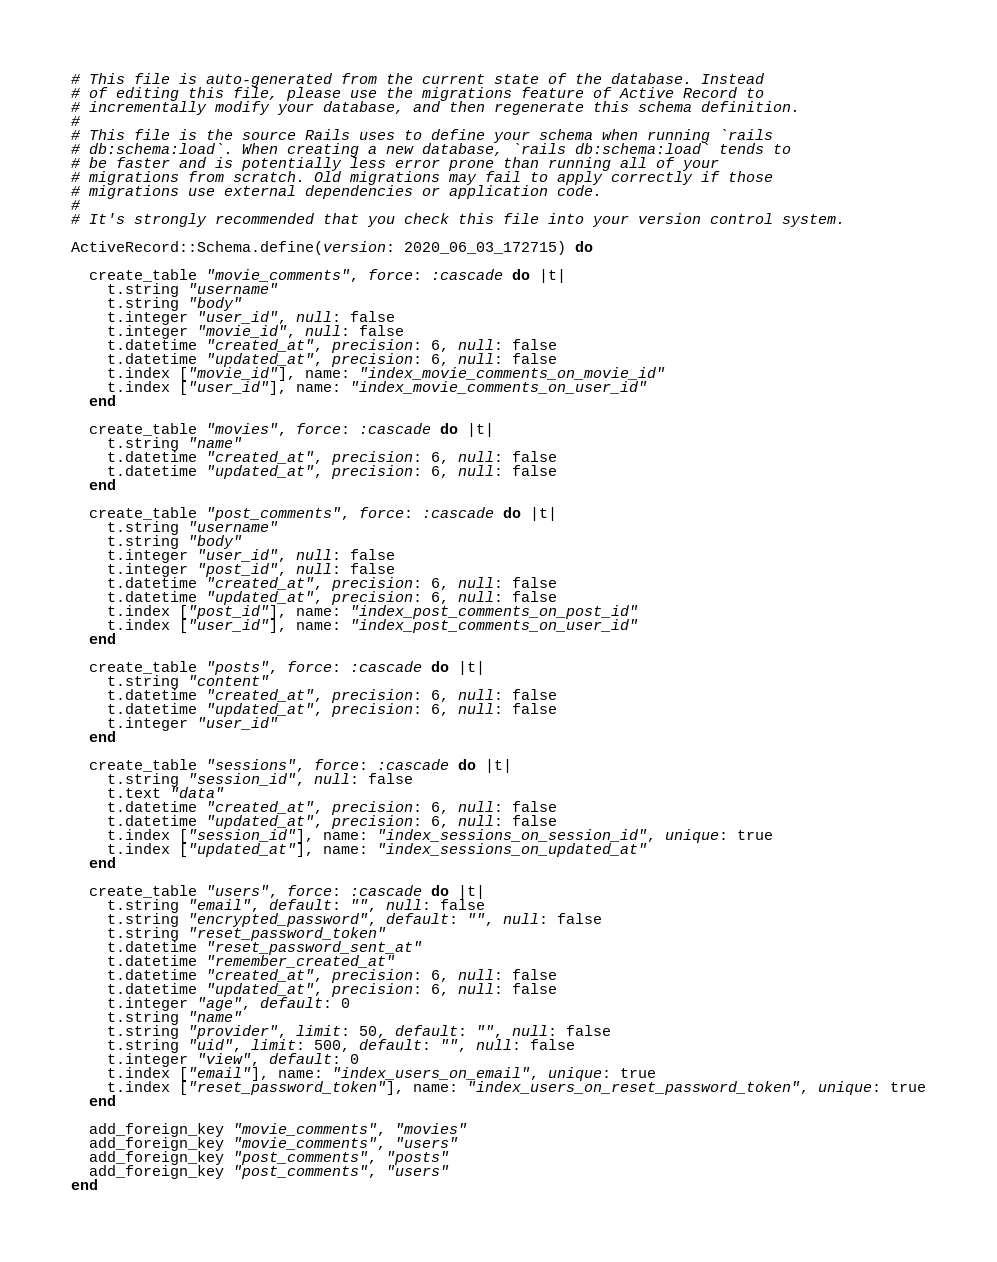<code> <loc_0><loc_0><loc_500><loc_500><_Ruby_># This file is auto-generated from the current state of the database. Instead
# of editing this file, please use the migrations feature of Active Record to
# incrementally modify your database, and then regenerate this schema definition.
#
# This file is the source Rails uses to define your schema when running `rails
# db:schema:load`. When creating a new database, `rails db:schema:load` tends to
# be faster and is potentially less error prone than running all of your
# migrations from scratch. Old migrations may fail to apply correctly if those
# migrations use external dependencies or application code.
#
# It's strongly recommended that you check this file into your version control system.

ActiveRecord::Schema.define(version: 2020_06_03_172715) do

  create_table "movie_comments", force: :cascade do |t|
    t.string "username"
    t.string "body"
    t.integer "user_id", null: false
    t.integer "movie_id", null: false
    t.datetime "created_at", precision: 6, null: false
    t.datetime "updated_at", precision: 6, null: false
    t.index ["movie_id"], name: "index_movie_comments_on_movie_id"
    t.index ["user_id"], name: "index_movie_comments_on_user_id"
  end

  create_table "movies", force: :cascade do |t|
    t.string "name"
    t.datetime "created_at", precision: 6, null: false
    t.datetime "updated_at", precision: 6, null: false
  end

  create_table "post_comments", force: :cascade do |t|
    t.string "username"
    t.string "body"
    t.integer "user_id", null: false
    t.integer "post_id", null: false
    t.datetime "created_at", precision: 6, null: false
    t.datetime "updated_at", precision: 6, null: false
    t.index ["post_id"], name: "index_post_comments_on_post_id"
    t.index ["user_id"], name: "index_post_comments_on_user_id"
  end

  create_table "posts", force: :cascade do |t|
    t.string "content"
    t.datetime "created_at", precision: 6, null: false
    t.datetime "updated_at", precision: 6, null: false
    t.integer "user_id"
  end

  create_table "sessions", force: :cascade do |t|
    t.string "session_id", null: false
    t.text "data"
    t.datetime "created_at", precision: 6, null: false
    t.datetime "updated_at", precision: 6, null: false
    t.index ["session_id"], name: "index_sessions_on_session_id", unique: true
    t.index ["updated_at"], name: "index_sessions_on_updated_at"
  end

  create_table "users", force: :cascade do |t|
    t.string "email", default: "", null: false
    t.string "encrypted_password", default: "", null: false
    t.string "reset_password_token"
    t.datetime "reset_password_sent_at"
    t.datetime "remember_created_at"
    t.datetime "created_at", precision: 6, null: false
    t.datetime "updated_at", precision: 6, null: false
    t.integer "age", default: 0
    t.string "name"
    t.string "provider", limit: 50, default: "", null: false
    t.string "uid", limit: 500, default: "", null: false
    t.integer "view", default: 0
    t.index ["email"], name: "index_users_on_email", unique: true
    t.index ["reset_password_token"], name: "index_users_on_reset_password_token", unique: true
  end

  add_foreign_key "movie_comments", "movies"
  add_foreign_key "movie_comments", "users"
  add_foreign_key "post_comments", "posts"
  add_foreign_key "post_comments", "users"
end
</code> 